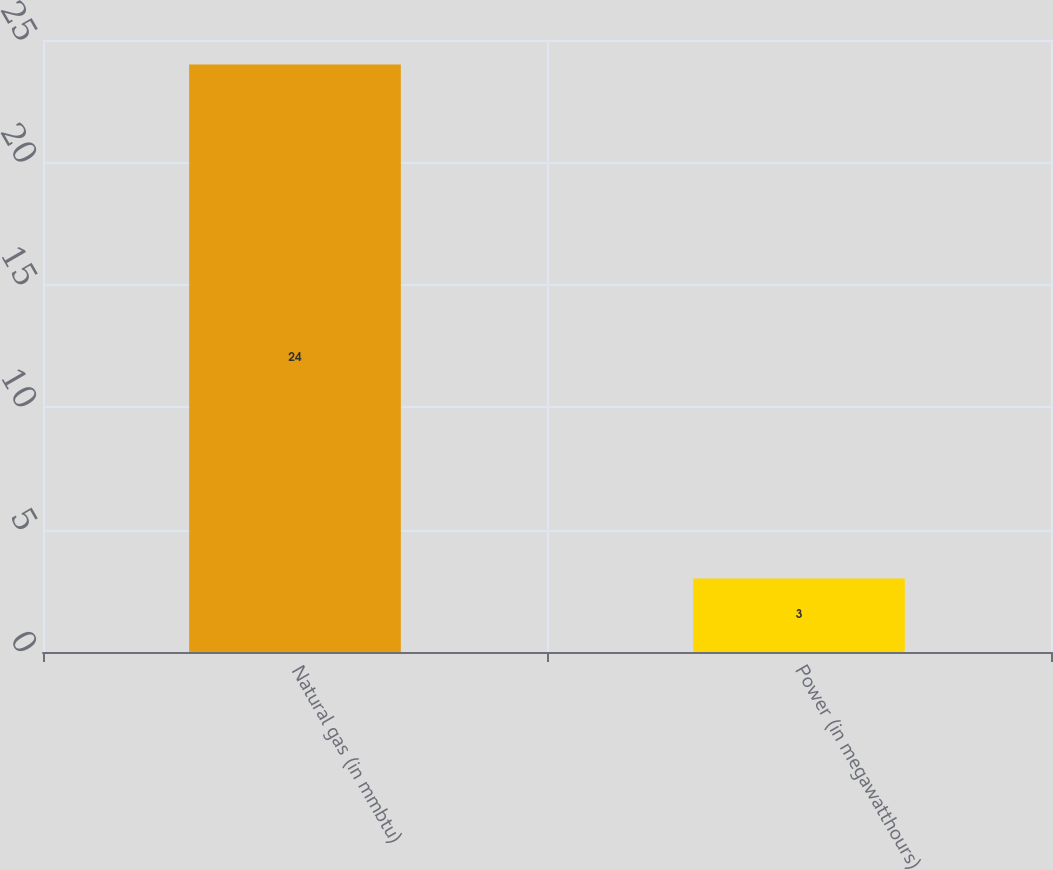<chart> <loc_0><loc_0><loc_500><loc_500><bar_chart><fcel>Natural gas (in mmbtu)<fcel>Power (in megawatthours)<nl><fcel>24<fcel>3<nl></chart> 